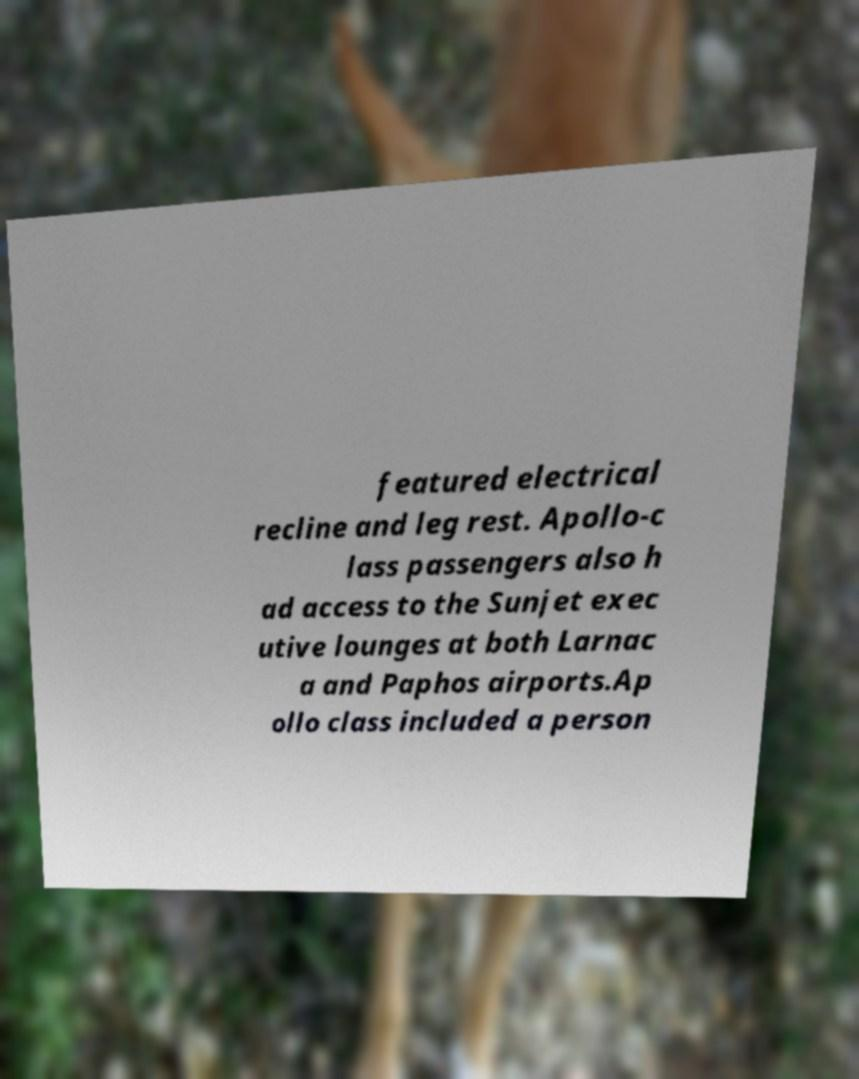Could you assist in decoding the text presented in this image and type it out clearly? featured electrical recline and leg rest. Apollo-c lass passengers also h ad access to the Sunjet exec utive lounges at both Larnac a and Paphos airports.Ap ollo class included a person 